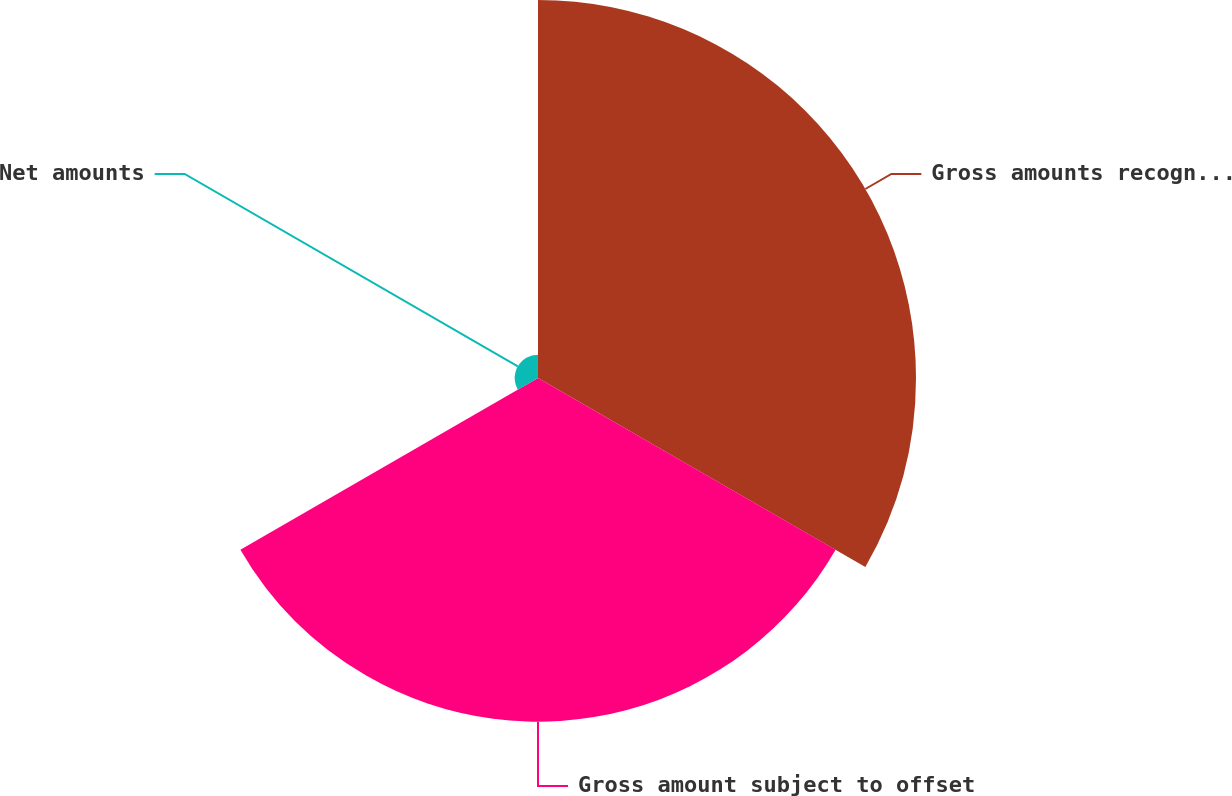Convert chart to OTSL. <chart><loc_0><loc_0><loc_500><loc_500><pie_chart><fcel>Gross amounts recognized in<fcel>Gross amount subject to offset<fcel>Net amounts<nl><fcel>50.74%<fcel>46.13%<fcel>3.13%<nl></chart> 